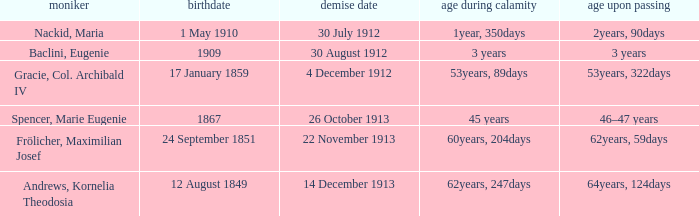When did the person born 24 September 1851 pass away? 22 November 1913. 